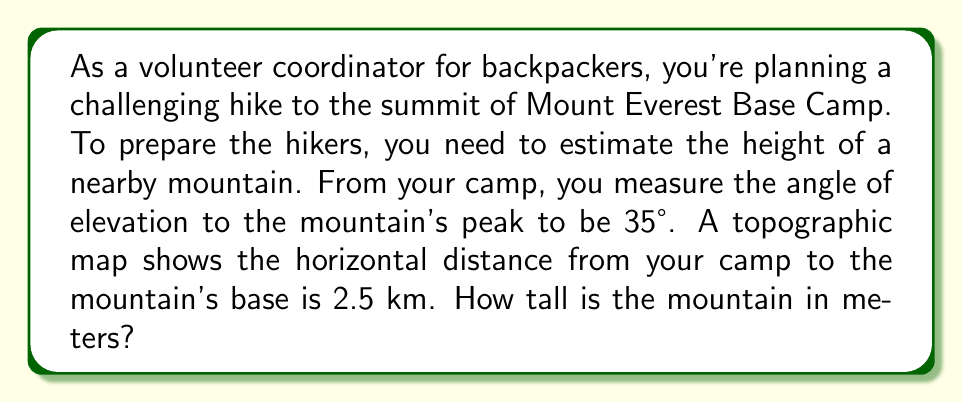Can you solve this math problem? Let's approach this step-by-step using trigonometry:

1) We can model this scenario as a right triangle, where:
   - The base of the triangle is the horizontal distance (2.5 km)
   - The height of the triangle is the mountain's height (what we're solving for)
   - The angle of elevation is 35°

2) In this right triangle, we know:
   - The adjacent side (horizontal distance) = 2.5 km = 2500 m
   - The angle of elevation = 35°
   - We need to find the opposite side (mountain height)

3) The trigonometric function that relates the opposite side to the adjacent side is the tangent:

   $$\tan(\theta) = \frac{\text{opposite}}{\text{adjacent}}$$

4) Let's call the mountain's height $h$. We can write:

   $$\tan(35°) = \frac{h}{2500}$$

5) To solve for $h$, we multiply both sides by 2500:

   $$h = 2500 \times \tan(35°)$$

6) Now we can calculate:
   $$h = 2500 \times \tan(35°) \approx 2500 \times 0.7002 \approx 1750.5$$

7) Rounding to the nearest meter:

   $$h \approx 1751 \text{ meters}$$

[asy]
import geometry;

size(200);

pair A = (0,0);
pair B = (5,0);
pair C = (5,3.5);

draw(A--B--C--A);

label("2.5 km", (2.5,0), S);
label("35°", (0.3,0.3), NW);
label("h", (5,1.75), E);

draw(rightanglemark(A,B,C,20));
[/asy]
Answer: 1751 meters 